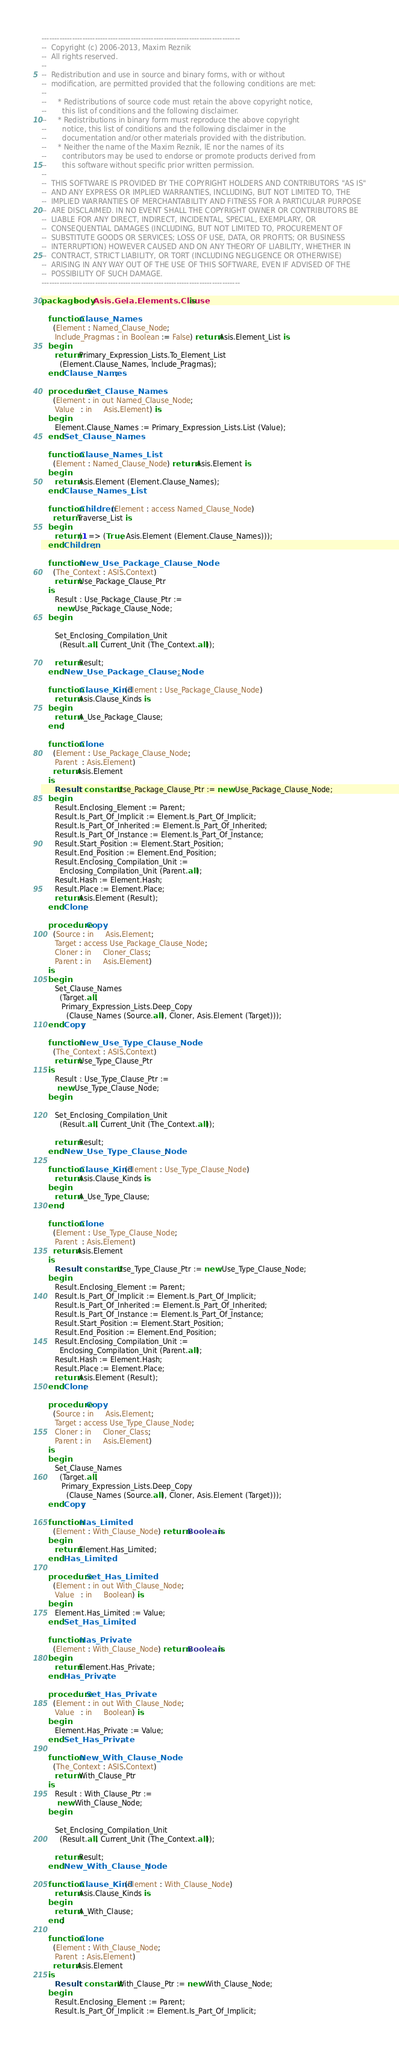Convert code to text. <code><loc_0><loc_0><loc_500><loc_500><_Ada_>
------------------------------------------------------------------------------
--  Copyright (c) 2006-2013, Maxim Reznik
--  All rights reserved.
--
--  Redistribution and use in source and binary forms, with or without
--  modification, are permitted provided that the following conditions are met:
--
--     * Redistributions of source code must retain the above copyright notice,
--       this list of conditions and the following disclaimer.
--     * Redistributions in binary form must reproduce the above copyright
--       notice, this list of conditions and the following disclaimer in the
--       documentation and/or other materials provided with the distribution.
--     * Neither the name of the Maxim Reznik, IE nor the names of its
--       contributors may be used to endorse or promote products derived from
--       this software without specific prior written permission.
--
--  THIS SOFTWARE IS PROVIDED BY THE COPYRIGHT HOLDERS AND CONTRIBUTORS "AS IS"
--  AND ANY EXPRESS OR IMPLIED WARRANTIES, INCLUDING, BUT NOT LIMITED TO, THE
--  IMPLIED WARRANTIES OF MERCHANTABILITY AND FITNESS FOR A PARTICULAR PURPOSE
--  ARE DISCLAIMED. IN NO EVENT SHALL THE COPYRIGHT OWNER OR CONTRIBUTORS BE
--  LIABLE FOR ANY DIRECT, INDIRECT, INCIDENTAL, SPECIAL, EXEMPLARY, OR
--  CONSEQUENTIAL DAMAGES (INCLUDING, BUT NOT LIMITED TO, PROCUREMENT OF
--  SUBSTITUTE GOODS OR SERVICES; LOSS OF USE, DATA, OR PROFITS; OR BUSINESS
--  INTERRUPTION) HOWEVER CAUSED AND ON ANY THEORY OF LIABILITY, WHETHER IN
--  CONTRACT, STRICT LIABILITY, OR TORT (INCLUDING NEGLIGENCE OR OTHERWISE)
--  ARISING IN ANY WAY OUT OF THE USE OF THIS SOFTWARE, EVEN IF ADVISED OF THE
--  POSSIBILITY OF SUCH DAMAGE.
------------------------------------------------------------------------------

package body Asis.Gela.Elements.Clause is

   function Clause_Names
     (Element : Named_Clause_Node;
      Include_Pragmas : in Boolean := False) return Asis.Element_List is
   begin
      return Primary_Expression_Lists.To_Element_List
        (Element.Clause_Names, Include_Pragmas);
   end Clause_Names;

   procedure Set_Clause_Names
     (Element : in out Named_Clause_Node;
      Value   : in     Asis.Element) is
   begin
      Element.Clause_Names := Primary_Expression_Lists.List (Value);
   end Set_Clause_Names;

   function Clause_Names_List
     (Element : Named_Clause_Node) return Asis.Element is
   begin
      return Asis.Element (Element.Clause_Names);
   end Clause_Names_List;

   function Children (Element : access Named_Clause_Node)
     return Traverse_List is
   begin
      return (1 => (True, Asis.Element (Element.Clause_Names)));
   end Children;

   function New_Use_Package_Clause_Node
     (The_Context : ASIS.Context)
      return Use_Package_Clause_Ptr
   is
      Result : Use_Package_Clause_Ptr :=
       new Use_Package_Clause_Node;
   begin

      Set_Enclosing_Compilation_Unit
        (Result.all, Current_Unit (The_Context.all));

      return Result;
   end New_Use_Package_Clause_Node;
  
   function Clause_Kind (Element : Use_Package_Clause_Node)
      return Asis.Clause_Kinds is
   begin
      return A_Use_Package_Clause;
   end;

   function Clone
     (Element : Use_Package_Clause_Node;
      Parent  : Asis.Element)
     return Asis.Element
   is
      Result : constant Use_Package_Clause_Ptr := new Use_Package_Clause_Node;
   begin
      Result.Enclosing_Element := Parent;
      Result.Is_Part_Of_Implicit := Element.Is_Part_Of_Implicit;
      Result.Is_Part_Of_Inherited := Element.Is_Part_Of_Inherited;
      Result.Is_Part_Of_Instance := Element.Is_Part_Of_Instance;
      Result.Start_Position := Element.Start_Position;
      Result.End_Position := Element.End_Position;
      Result.Enclosing_Compilation_Unit :=
        Enclosing_Compilation_Unit (Parent.all);
      Result.Hash := Element.Hash;
      Result.Place := Element.Place;
      return Asis.Element (Result);
   end Clone;

   procedure Copy
     (Source : in     Asis.Element;
      Target : access Use_Package_Clause_Node;
      Cloner : in     Cloner_Class;
      Parent : in     Asis.Element)
   is
   begin
      Set_Clause_Names
        (Target.all,
         Primary_Expression_Lists.Deep_Copy 
           (Clause_Names (Source.all), Cloner, Asis.Element (Target)));
   end Copy;

   function New_Use_Type_Clause_Node
     (The_Context : ASIS.Context)
      return Use_Type_Clause_Ptr
   is
      Result : Use_Type_Clause_Ptr :=
       new Use_Type_Clause_Node;
   begin

      Set_Enclosing_Compilation_Unit
        (Result.all, Current_Unit (The_Context.all));

      return Result;
   end New_Use_Type_Clause_Node;
  
   function Clause_Kind (Element : Use_Type_Clause_Node)
      return Asis.Clause_Kinds is
   begin
      return A_Use_Type_Clause;
   end;

   function Clone
     (Element : Use_Type_Clause_Node;
      Parent  : Asis.Element)
     return Asis.Element
   is
      Result : constant Use_Type_Clause_Ptr := new Use_Type_Clause_Node;
   begin
      Result.Enclosing_Element := Parent;
      Result.Is_Part_Of_Implicit := Element.Is_Part_Of_Implicit;
      Result.Is_Part_Of_Inherited := Element.Is_Part_Of_Inherited;
      Result.Is_Part_Of_Instance := Element.Is_Part_Of_Instance;
      Result.Start_Position := Element.Start_Position;
      Result.End_Position := Element.End_Position;
      Result.Enclosing_Compilation_Unit :=
        Enclosing_Compilation_Unit (Parent.all);
      Result.Hash := Element.Hash;
      Result.Place := Element.Place;
      return Asis.Element (Result);
   end Clone;

   procedure Copy
     (Source : in     Asis.Element;
      Target : access Use_Type_Clause_Node;
      Cloner : in     Cloner_Class;
      Parent : in     Asis.Element)
   is
   begin
      Set_Clause_Names
        (Target.all,
         Primary_Expression_Lists.Deep_Copy 
           (Clause_Names (Source.all), Cloner, Asis.Element (Target)));
   end Copy;

   function Has_Limited
     (Element : With_Clause_Node) return Boolean is
   begin
      return Element.Has_Limited;
   end Has_Limited;

   procedure Set_Has_Limited
     (Element : in out With_Clause_Node;
      Value   : in     Boolean) is
   begin
      Element.Has_Limited := Value;
   end Set_Has_Limited;

   function Has_Private
     (Element : With_Clause_Node) return Boolean is
   begin
      return Element.Has_Private;
   end Has_Private;

   procedure Set_Has_Private
     (Element : in out With_Clause_Node;
      Value   : in     Boolean) is
   begin
      Element.Has_Private := Value;
   end Set_Has_Private;

   function New_With_Clause_Node
     (The_Context : ASIS.Context)
      return With_Clause_Ptr
   is
      Result : With_Clause_Ptr :=
       new With_Clause_Node;
   begin

      Set_Enclosing_Compilation_Unit
        (Result.all, Current_Unit (The_Context.all));

      return Result;
   end New_With_Clause_Node;
  
   function Clause_Kind (Element : With_Clause_Node)
      return Asis.Clause_Kinds is
   begin
      return A_With_Clause;
   end;

   function Clone
     (Element : With_Clause_Node;
      Parent  : Asis.Element)
     return Asis.Element
   is
      Result : constant With_Clause_Ptr := new With_Clause_Node;
   begin
      Result.Enclosing_Element := Parent;
      Result.Is_Part_Of_Implicit := Element.Is_Part_Of_Implicit;</code> 